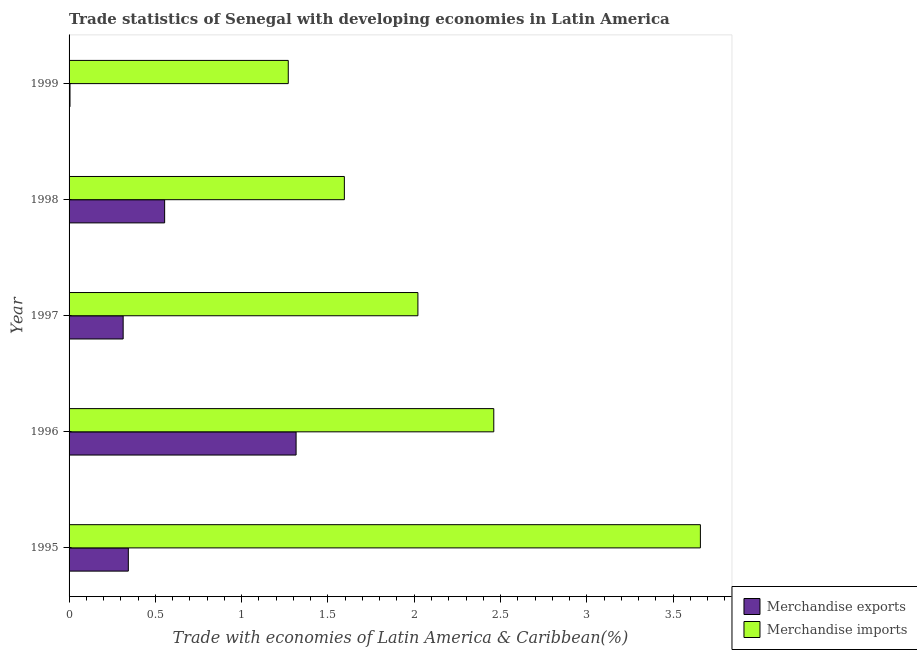How many groups of bars are there?
Keep it short and to the point. 5. How many bars are there on the 5th tick from the bottom?
Provide a short and direct response. 2. What is the label of the 3rd group of bars from the top?
Offer a terse response. 1997. In how many cases, is the number of bars for a given year not equal to the number of legend labels?
Your answer should be compact. 0. What is the merchandise imports in 1996?
Your answer should be compact. 2.46. Across all years, what is the maximum merchandise exports?
Offer a terse response. 1.32. Across all years, what is the minimum merchandise imports?
Your response must be concise. 1.27. In which year was the merchandise imports minimum?
Give a very brief answer. 1999. What is the total merchandise imports in the graph?
Your response must be concise. 11.01. What is the difference between the merchandise imports in 1996 and that in 1997?
Give a very brief answer. 0.44. What is the difference between the merchandise exports in 1998 and the merchandise imports in 1996?
Offer a terse response. -1.91. What is the average merchandise imports per year?
Give a very brief answer. 2.2. In the year 1995, what is the difference between the merchandise imports and merchandise exports?
Your response must be concise. 3.31. In how many years, is the merchandise imports greater than 1.1 %?
Ensure brevity in your answer.  5. What is the ratio of the merchandise exports in 1996 to that in 1997?
Your answer should be compact. 4.2. Is the merchandise imports in 1995 less than that in 1999?
Provide a short and direct response. No. What is the difference between the highest and the second highest merchandise imports?
Provide a succinct answer. 1.2. What is the difference between the highest and the lowest merchandise imports?
Your answer should be compact. 2.39. Is the sum of the merchandise imports in 1995 and 1996 greater than the maximum merchandise exports across all years?
Your answer should be compact. Yes. What does the 1st bar from the top in 1996 represents?
Provide a succinct answer. Merchandise imports. What does the 2nd bar from the bottom in 1995 represents?
Provide a short and direct response. Merchandise imports. Are all the bars in the graph horizontal?
Your response must be concise. Yes. How many years are there in the graph?
Make the answer very short. 5. What is the difference between two consecutive major ticks on the X-axis?
Your response must be concise. 0.5. Does the graph contain any zero values?
Your answer should be very brief. No. Where does the legend appear in the graph?
Offer a very short reply. Bottom right. How many legend labels are there?
Offer a terse response. 2. How are the legend labels stacked?
Make the answer very short. Vertical. What is the title of the graph?
Ensure brevity in your answer.  Trade statistics of Senegal with developing economies in Latin America. Does "Primary completion rate" appear as one of the legend labels in the graph?
Your answer should be compact. No. What is the label or title of the X-axis?
Give a very brief answer. Trade with economies of Latin America & Caribbean(%). What is the Trade with economies of Latin America & Caribbean(%) in Merchandise exports in 1995?
Your response must be concise. 0.34. What is the Trade with economies of Latin America & Caribbean(%) of Merchandise imports in 1995?
Provide a succinct answer. 3.66. What is the Trade with economies of Latin America & Caribbean(%) of Merchandise exports in 1996?
Provide a succinct answer. 1.32. What is the Trade with economies of Latin America & Caribbean(%) of Merchandise imports in 1996?
Make the answer very short. 2.46. What is the Trade with economies of Latin America & Caribbean(%) in Merchandise exports in 1997?
Provide a short and direct response. 0.31. What is the Trade with economies of Latin America & Caribbean(%) in Merchandise imports in 1997?
Offer a terse response. 2.02. What is the Trade with economies of Latin America & Caribbean(%) of Merchandise exports in 1998?
Your answer should be compact. 0.55. What is the Trade with economies of Latin America & Caribbean(%) of Merchandise imports in 1998?
Provide a short and direct response. 1.6. What is the Trade with economies of Latin America & Caribbean(%) in Merchandise exports in 1999?
Your response must be concise. 0.01. What is the Trade with economies of Latin America & Caribbean(%) in Merchandise imports in 1999?
Give a very brief answer. 1.27. Across all years, what is the maximum Trade with economies of Latin America & Caribbean(%) in Merchandise exports?
Give a very brief answer. 1.32. Across all years, what is the maximum Trade with economies of Latin America & Caribbean(%) in Merchandise imports?
Provide a short and direct response. 3.66. Across all years, what is the minimum Trade with economies of Latin America & Caribbean(%) in Merchandise exports?
Your answer should be compact. 0.01. Across all years, what is the minimum Trade with economies of Latin America & Caribbean(%) of Merchandise imports?
Make the answer very short. 1.27. What is the total Trade with economies of Latin America & Caribbean(%) of Merchandise exports in the graph?
Keep it short and to the point. 2.53. What is the total Trade with economies of Latin America & Caribbean(%) in Merchandise imports in the graph?
Give a very brief answer. 11.01. What is the difference between the Trade with economies of Latin America & Caribbean(%) in Merchandise exports in 1995 and that in 1996?
Your response must be concise. -0.97. What is the difference between the Trade with economies of Latin America & Caribbean(%) of Merchandise imports in 1995 and that in 1996?
Offer a very short reply. 1.2. What is the difference between the Trade with economies of Latin America & Caribbean(%) in Merchandise exports in 1995 and that in 1997?
Your response must be concise. 0.03. What is the difference between the Trade with economies of Latin America & Caribbean(%) of Merchandise imports in 1995 and that in 1997?
Provide a short and direct response. 1.64. What is the difference between the Trade with economies of Latin America & Caribbean(%) in Merchandise exports in 1995 and that in 1998?
Provide a short and direct response. -0.21. What is the difference between the Trade with economies of Latin America & Caribbean(%) of Merchandise imports in 1995 and that in 1998?
Offer a very short reply. 2.06. What is the difference between the Trade with economies of Latin America & Caribbean(%) of Merchandise exports in 1995 and that in 1999?
Keep it short and to the point. 0.34. What is the difference between the Trade with economies of Latin America & Caribbean(%) in Merchandise imports in 1995 and that in 1999?
Ensure brevity in your answer.  2.39. What is the difference between the Trade with economies of Latin America & Caribbean(%) in Merchandise exports in 1996 and that in 1997?
Ensure brevity in your answer.  1. What is the difference between the Trade with economies of Latin America & Caribbean(%) in Merchandise imports in 1996 and that in 1997?
Provide a succinct answer. 0.44. What is the difference between the Trade with economies of Latin America & Caribbean(%) in Merchandise exports in 1996 and that in 1998?
Your response must be concise. 0.76. What is the difference between the Trade with economies of Latin America & Caribbean(%) of Merchandise imports in 1996 and that in 1998?
Your response must be concise. 0.87. What is the difference between the Trade with economies of Latin America & Caribbean(%) in Merchandise exports in 1996 and that in 1999?
Keep it short and to the point. 1.31. What is the difference between the Trade with economies of Latin America & Caribbean(%) of Merchandise imports in 1996 and that in 1999?
Your response must be concise. 1.19. What is the difference between the Trade with economies of Latin America & Caribbean(%) of Merchandise exports in 1997 and that in 1998?
Your response must be concise. -0.24. What is the difference between the Trade with economies of Latin America & Caribbean(%) of Merchandise imports in 1997 and that in 1998?
Offer a terse response. 0.43. What is the difference between the Trade with economies of Latin America & Caribbean(%) of Merchandise exports in 1997 and that in 1999?
Offer a terse response. 0.31. What is the difference between the Trade with economies of Latin America & Caribbean(%) in Merchandise imports in 1997 and that in 1999?
Make the answer very short. 0.75. What is the difference between the Trade with economies of Latin America & Caribbean(%) of Merchandise exports in 1998 and that in 1999?
Make the answer very short. 0.55. What is the difference between the Trade with economies of Latin America & Caribbean(%) of Merchandise imports in 1998 and that in 1999?
Your answer should be compact. 0.33. What is the difference between the Trade with economies of Latin America & Caribbean(%) in Merchandise exports in 1995 and the Trade with economies of Latin America & Caribbean(%) in Merchandise imports in 1996?
Offer a very short reply. -2.12. What is the difference between the Trade with economies of Latin America & Caribbean(%) in Merchandise exports in 1995 and the Trade with economies of Latin America & Caribbean(%) in Merchandise imports in 1997?
Offer a very short reply. -1.68. What is the difference between the Trade with economies of Latin America & Caribbean(%) in Merchandise exports in 1995 and the Trade with economies of Latin America & Caribbean(%) in Merchandise imports in 1998?
Make the answer very short. -1.25. What is the difference between the Trade with economies of Latin America & Caribbean(%) of Merchandise exports in 1995 and the Trade with economies of Latin America & Caribbean(%) of Merchandise imports in 1999?
Offer a terse response. -0.93. What is the difference between the Trade with economies of Latin America & Caribbean(%) of Merchandise exports in 1996 and the Trade with economies of Latin America & Caribbean(%) of Merchandise imports in 1997?
Your answer should be compact. -0.71. What is the difference between the Trade with economies of Latin America & Caribbean(%) of Merchandise exports in 1996 and the Trade with economies of Latin America & Caribbean(%) of Merchandise imports in 1998?
Give a very brief answer. -0.28. What is the difference between the Trade with economies of Latin America & Caribbean(%) in Merchandise exports in 1996 and the Trade with economies of Latin America & Caribbean(%) in Merchandise imports in 1999?
Your answer should be compact. 0.05. What is the difference between the Trade with economies of Latin America & Caribbean(%) of Merchandise exports in 1997 and the Trade with economies of Latin America & Caribbean(%) of Merchandise imports in 1998?
Keep it short and to the point. -1.28. What is the difference between the Trade with economies of Latin America & Caribbean(%) of Merchandise exports in 1997 and the Trade with economies of Latin America & Caribbean(%) of Merchandise imports in 1999?
Provide a succinct answer. -0.96. What is the difference between the Trade with economies of Latin America & Caribbean(%) of Merchandise exports in 1998 and the Trade with economies of Latin America & Caribbean(%) of Merchandise imports in 1999?
Provide a short and direct response. -0.72. What is the average Trade with economies of Latin America & Caribbean(%) in Merchandise exports per year?
Ensure brevity in your answer.  0.51. What is the average Trade with economies of Latin America & Caribbean(%) of Merchandise imports per year?
Provide a succinct answer. 2.2. In the year 1995, what is the difference between the Trade with economies of Latin America & Caribbean(%) of Merchandise exports and Trade with economies of Latin America & Caribbean(%) of Merchandise imports?
Your response must be concise. -3.31. In the year 1996, what is the difference between the Trade with economies of Latin America & Caribbean(%) of Merchandise exports and Trade with economies of Latin America & Caribbean(%) of Merchandise imports?
Your answer should be very brief. -1.15. In the year 1997, what is the difference between the Trade with economies of Latin America & Caribbean(%) in Merchandise exports and Trade with economies of Latin America & Caribbean(%) in Merchandise imports?
Your answer should be compact. -1.71. In the year 1998, what is the difference between the Trade with economies of Latin America & Caribbean(%) of Merchandise exports and Trade with economies of Latin America & Caribbean(%) of Merchandise imports?
Provide a short and direct response. -1.04. In the year 1999, what is the difference between the Trade with economies of Latin America & Caribbean(%) of Merchandise exports and Trade with economies of Latin America & Caribbean(%) of Merchandise imports?
Keep it short and to the point. -1.26. What is the ratio of the Trade with economies of Latin America & Caribbean(%) of Merchandise exports in 1995 to that in 1996?
Provide a succinct answer. 0.26. What is the ratio of the Trade with economies of Latin America & Caribbean(%) of Merchandise imports in 1995 to that in 1996?
Provide a short and direct response. 1.49. What is the ratio of the Trade with economies of Latin America & Caribbean(%) in Merchandise exports in 1995 to that in 1997?
Provide a short and direct response. 1.1. What is the ratio of the Trade with economies of Latin America & Caribbean(%) in Merchandise imports in 1995 to that in 1997?
Your response must be concise. 1.81. What is the ratio of the Trade with economies of Latin America & Caribbean(%) in Merchandise exports in 1995 to that in 1998?
Your answer should be compact. 0.62. What is the ratio of the Trade with economies of Latin America & Caribbean(%) in Merchandise imports in 1995 to that in 1998?
Your answer should be very brief. 2.29. What is the ratio of the Trade with economies of Latin America & Caribbean(%) of Merchandise exports in 1995 to that in 1999?
Ensure brevity in your answer.  63.89. What is the ratio of the Trade with economies of Latin America & Caribbean(%) in Merchandise imports in 1995 to that in 1999?
Give a very brief answer. 2.88. What is the ratio of the Trade with economies of Latin America & Caribbean(%) in Merchandise exports in 1996 to that in 1997?
Offer a terse response. 4.2. What is the ratio of the Trade with economies of Latin America & Caribbean(%) in Merchandise imports in 1996 to that in 1997?
Your response must be concise. 1.22. What is the ratio of the Trade with economies of Latin America & Caribbean(%) of Merchandise exports in 1996 to that in 1998?
Keep it short and to the point. 2.38. What is the ratio of the Trade with economies of Latin America & Caribbean(%) of Merchandise imports in 1996 to that in 1998?
Give a very brief answer. 1.54. What is the ratio of the Trade with economies of Latin America & Caribbean(%) in Merchandise exports in 1996 to that in 1999?
Your response must be concise. 244.79. What is the ratio of the Trade with economies of Latin America & Caribbean(%) in Merchandise imports in 1996 to that in 1999?
Your answer should be very brief. 1.94. What is the ratio of the Trade with economies of Latin America & Caribbean(%) in Merchandise exports in 1997 to that in 1998?
Offer a terse response. 0.57. What is the ratio of the Trade with economies of Latin America & Caribbean(%) in Merchandise imports in 1997 to that in 1998?
Give a very brief answer. 1.27. What is the ratio of the Trade with economies of Latin America & Caribbean(%) in Merchandise exports in 1997 to that in 1999?
Offer a terse response. 58.32. What is the ratio of the Trade with economies of Latin America & Caribbean(%) of Merchandise imports in 1997 to that in 1999?
Ensure brevity in your answer.  1.59. What is the ratio of the Trade with economies of Latin America & Caribbean(%) of Merchandise exports in 1998 to that in 1999?
Provide a succinct answer. 103.05. What is the ratio of the Trade with economies of Latin America & Caribbean(%) of Merchandise imports in 1998 to that in 1999?
Give a very brief answer. 1.26. What is the difference between the highest and the second highest Trade with economies of Latin America & Caribbean(%) of Merchandise exports?
Offer a very short reply. 0.76. What is the difference between the highest and the second highest Trade with economies of Latin America & Caribbean(%) of Merchandise imports?
Give a very brief answer. 1.2. What is the difference between the highest and the lowest Trade with economies of Latin America & Caribbean(%) of Merchandise exports?
Offer a very short reply. 1.31. What is the difference between the highest and the lowest Trade with economies of Latin America & Caribbean(%) in Merchandise imports?
Provide a short and direct response. 2.39. 